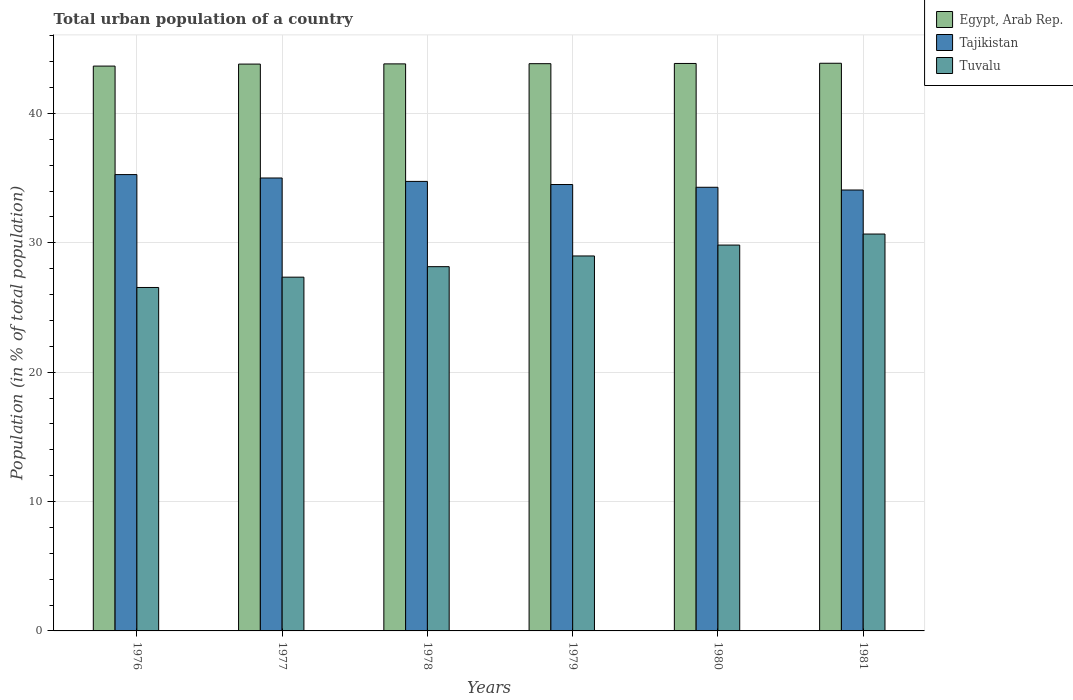Are the number of bars on each tick of the X-axis equal?
Offer a terse response. Yes. How many bars are there on the 4th tick from the right?
Provide a succinct answer. 3. What is the label of the 6th group of bars from the left?
Your answer should be very brief. 1981. What is the urban population in Tajikistan in 1980?
Make the answer very short. 34.29. Across all years, what is the maximum urban population in Tuvalu?
Your response must be concise. 30.68. Across all years, what is the minimum urban population in Tajikistan?
Your response must be concise. 34.08. In which year was the urban population in Egypt, Arab Rep. minimum?
Offer a very short reply. 1976. What is the total urban population in Egypt, Arab Rep. in the graph?
Your response must be concise. 262.87. What is the difference between the urban population in Tajikistan in 1977 and that in 1980?
Ensure brevity in your answer.  0.72. What is the difference between the urban population in Egypt, Arab Rep. in 1977 and the urban population in Tuvalu in 1976?
Offer a terse response. 17.27. What is the average urban population in Egypt, Arab Rep. per year?
Offer a very short reply. 43.81. In the year 1979, what is the difference between the urban population in Egypt, Arab Rep. and urban population in Tuvalu?
Make the answer very short. 14.86. What is the ratio of the urban population in Tuvalu in 1976 to that in 1978?
Your answer should be compact. 0.94. What is the difference between the highest and the second highest urban population in Tuvalu?
Give a very brief answer. 0.85. What is the difference between the highest and the lowest urban population in Tuvalu?
Your answer should be compact. 4.13. In how many years, is the urban population in Tajikistan greater than the average urban population in Tajikistan taken over all years?
Keep it short and to the point. 3. Is the sum of the urban population in Tajikistan in 1977 and 1978 greater than the maximum urban population in Tuvalu across all years?
Your answer should be very brief. Yes. What does the 3rd bar from the left in 1977 represents?
Ensure brevity in your answer.  Tuvalu. What does the 1st bar from the right in 1976 represents?
Offer a very short reply. Tuvalu. How many bars are there?
Offer a terse response. 18. Are all the bars in the graph horizontal?
Offer a very short reply. No. What is the difference between two consecutive major ticks on the Y-axis?
Your response must be concise. 10. Does the graph contain any zero values?
Your answer should be very brief. No. Does the graph contain grids?
Your answer should be very brief. Yes. What is the title of the graph?
Ensure brevity in your answer.  Total urban population of a country. Does "Georgia" appear as one of the legend labels in the graph?
Provide a succinct answer. No. What is the label or title of the X-axis?
Keep it short and to the point. Years. What is the label or title of the Y-axis?
Offer a very short reply. Population (in % of total population). What is the Population (in % of total population) of Egypt, Arab Rep. in 1976?
Offer a terse response. 43.66. What is the Population (in % of total population) of Tajikistan in 1976?
Ensure brevity in your answer.  35.27. What is the Population (in % of total population) of Tuvalu in 1976?
Ensure brevity in your answer.  26.55. What is the Population (in % of total population) of Egypt, Arab Rep. in 1977?
Provide a short and direct response. 43.81. What is the Population (in % of total population) in Tajikistan in 1977?
Offer a terse response. 35.01. What is the Population (in % of total population) in Tuvalu in 1977?
Offer a very short reply. 27.34. What is the Population (in % of total population) in Egypt, Arab Rep. in 1978?
Offer a very short reply. 43.83. What is the Population (in % of total population) in Tajikistan in 1978?
Provide a succinct answer. 34.74. What is the Population (in % of total population) of Tuvalu in 1978?
Give a very brief answer. 28.15. What is the Population (in % of total population) in Egypt, Arab Rep. in 1979?
Ensure brevity in your answer.  43.84. What is the Population (in % of total population) of Tajikistan in 1979?
Ensure brevity in your answer.  34.5. What is the Population (in % of total population) of Tuvalu in 1979?
Provide a short and direct response. 28.98. What is the Population (in % of total population) in Egypt, Arab Rep. in 1980?
Make the answer very short. 43.86. What is the Population (in % of total population) in Tajikistan in 1980?
Offer a terse response. 34.29. What is the Population (in % of total population) in Tuvalu in 1980?
Give a very brief answer. 29.82. What is the Population (in % of total population) of Egypt, Arab Rep. in 1981?
Make the answer very short. 43.87. What is the Population (in % of total population) of Tajikistan in 1981?
Your response must be concise. 34.08. What is the Population (in % of total population) of Tuvalu in 1981?
Give a very brief answer. 30.68. Across all years, what is the maximum Population (in % of total population) in Egypt, Arab Rep.?
Make the answer very short. 43.87. Across all years, what is the maximum Population (in % of total population) in Tajikistan?
Your response must be concise. 35.27. Across all years, what is the maximum Population (in % of total population) of Tuvalu?
Ensure brevity in your answer.  30.68. Across all years, what is the minimum Population (in % of total population) of Egypt, Arab Rep.?
Keep it short and to the point. 43.66. Across all years, what is the minimum Population (in % of total population) in Tajikistan?
Make the answer very short. 34.08. Across all years, what is the minimum Population (in % of total population) of Tuvalu?
Your answer should be compact. 26.55. What is the total Population (in % of total population) of Egypt, Arab Rep. in the graph?
Provide a succinct answer. 262.87. What is the total Population (in % of total population) in Tajikistan in the graph?
Give a very brief answer. 207.89. What is the total Population (in % of total population) in Tuvalu in the graph?
Keep it short and to the point. 171.52. What is the difference between the Population (in % of total population) of Egypt, Arab Rep. in 1976 and that in 1977?
Give a very brief answer. -0.15. What is the difference between the Population (in % of total population) of Tajikistan in 1976 and that in 1977?
Make the answer very short. 0.26. What is the difference between the Population (in % of total population) in Tuvalu in 1976 and that in 1977?
Ensure brevity in your answer.  -0.8. What is the difference between the Population (in % of total population) of Egypt, Arab Rep. in 1976 and that in 1978?
Offer a very short reply. -0.17. What is the difference between the Population (in % of total population) in Tajikistan in 1976 and that in 1978?
Offer a terse response. 0.53. What is the difference between the Population (in % of total population) of Tuvalu in 1976 and that in 1978?
Keep it short and to the point. -1.61. What is the difference between the Population (in % of total population) of Egypt, Arab Rep. in 1976 and that in 1979?
Ensure brevity in your answer.  -0.19. What is the difference between the Population (in % of total population) in Tajikistan in 1976 and that in 1979?
Provide a short and direct response. 0.77. What is the difference between the Population (in % of total population) of Tuvalu in 1976 and that in 1979?
Your answer should be very brief. -2.44. What is the difference between the Population (in % of total population) in Egypt, Arab Rep. in 1976 and that in 1980?
Give a very brief answer. -0.2. What is the difference between the Population (in % of total population) of Tajikistan in 1976 and that in 1980?
Provide a short and direct response. 0.98. What is the difference between the Population (in % of total population) in Tuvalu in 1976 and that in 1980?
Make the answer very short. -3.28. What is the difference between the Population (in % of total population) in Egypt, Arab Rep. in 1976 and that in 1981?
Give a very brief answer. -0.22. What is the difference between the Population (in % of total population) of Tajikistan in 1976 and that in 1981?
Provide a short and direct response. 1.19. What is the difference between the Population (in % of total population) in Tuvalu in 1976 and that in 1981?
Provide a succinct answer. -4.13. What is the difference between the Population (in % of total population) in Egypt, Arab Rep. in 1977 and that in 1978?
Provide a succinct answer. -0.02. What is the difference between the Population (in % of total population) of Tajikistan in 1977 and that in 1978?
Provide a short and direct response. 0.26. What is the difference between the Population (in % of total population) of Tuvalu in 1977 and that in 1978?
Offer a terse response. -0.81. What is the difference between the Population (in % of total population) of Egypt, Arab Rep. in 1977 and that in 1979?
Give a very brief answer. -0.03. What is the difference between the Population (in % of total population) in Tajikistan in 1977 and that in 1979?
Your answer should be very brief. 0.5. What is the difference between the Population (in % of total population) of Tuvalu in 1977 and that in 1979?
Keep it short and to the point. -1.64. What is the difference between the Population (in % of total population) in Egypt, Arab Rep. in 1977 and that in 1980?
Offer a very short reply. -0.05. What is the difference between the Population (in % of total population) in Tajikistan in 1977 and that in 1980?
Ensure brevity in your answer.  0.72. What is the difference between the Population (in % of total population) of Tuvalu in 1977 and that in 1980?
Provide a succinct answer. -2.48. What is the difference between the Population (in % of total population) of Egypt, Arab Rep. in 1977 and that in 1981?
Provide a succinct answer. -0.06. What is the difference between the Population (in % of total population) of Tajikistan in 1977 and that in 1981?
Offer a very short reply. 0.93. What is the difference between the Population (in % of total population) of Tuvalu in 1977 and that in 1981?
Offer a terse response. -3.33. What is the difference between the Population (in % of total population) in Egypt, Arab Rep. in 1978 and that in 1979?
Ensure brevity in your answer.  -0.02. What is the difference between the Population (in % of total population) of Tajikistan in 1978 and that in 1979?
Your answer should be very brief. 0.24. What is the difference between the Population (in % of total population) of Tuvalu in 1978 and that in 1979?
Provide a short and direct response. -0.83. What is the difference between the Population (in % of total population) of Egypt, Arab Rep. in 1978 and that in 1980?
Your answer should be compact. -0.03. What is the difference between the Population (in % of total population) of Tajikistan in 1978 and that in 1980?
Provide a succinct answer. 0.45. What is the difference between the Population (in % of total population) in Tuvalu in 1978 and that in 1980?
Offer a very short reply. -1.67. What is the difference between the Population (in % of total population) in Egypt, Arab Rep. in 1978 and that in 1981?
Provide a succinct answer. -0.05. What is the difference between the Population (in % of total population) of Tajikistan in 1978 and that in 1981?
Provide a succinct answer. 0.67. What is the difference between the Population (in % of total population) of Tuvalu in 1978 and that in 1981?
Your answer should be compact. -2.52. What is the difference between the Population (in % of total population) of Egypt, Arab Rep. in 1979 and that in 1980?
Offer a very short reply. -0.02. What is the difference between the Population (in % of total population) in Tajikistan in 1979 and that in 1980?
Make the answer very short. 0.21. What is the difference between the Population (in % of total population) of Tuvalu in 1979 and that in 1980?
Give a very brief answer. -0.84. What is the difference between the Population (in % of total population) in Egypt, Arab Rep. in 1979 and that in 1981?
Give a very brief answer. -0.03. What is the difference between the Population (in % of total population) in Tajikistan in 1979 and that in 1981?
Provide a short and direct response. 0.42. What is the difference between the Population (in % of total population) in Tuvalu in 1979 and that in 1981?
Ensure brevity in your answer.  -1.7. What is the difference between the Population (in % of total population) of Egypt, Arab Rep. in 1980 and that in 1981?
Provide a succinct answer. -0.02. What is the difference between the Population (in % of total population) of Tajikistan in 1980 and that in 1981?
Offer a terse response. 0.21. What is the difference between the Population (in % of total population) of Tuvalu in 1980 and that in 1981?
Make the answer very short. -0.85. What is the difference between the Population (in % of total population) in Egypt, Arab Rep. in 1976 and the Population (in % of total population) in Tajikistan in 1977?
Keep it short and to the point. 8.65. What is the difference between the Population (in % of total population) of Egypt, Arab Rep. in 1976 and the Population (in % of total population) of Tuvalu in 1977?
Make the answer very short. 16.32. What is the difference between the Population (in % of total population) in Tajikistan in 1976 and the Population (in % of total population) in Tuvalu in 1977?
Ensure brevity in your answer.  7.93. What is the difference between the Population (in % of total population) in Egypt, Arab Rep. in 1976 and the Population (in % of total population) in Tajikistan in 1978?
Keep it short and to the point. 8.91. What is the difference between the Population (in % of total population) in Egypt, Arab Rep. in 1976 and the Population (in % of total population) in Tuvalu in 1978?
Give a very brief answer. 15.5. What is the difference between the Population (in % of total population) in Tajikistan in 1976 and the Population (in % of total population) in Tuvalu in 1978?
Your answer should be very brief. 7.12. What is the difference between the Population (in % of total population) in Egypt, Arab Rep. in 1976 and the Population (in % of total population) in Tajikistan in 1979?
Provide a short and direct response. 9.15. What is the difference between the Population (in % of total population) of Egypt, Arab Rep. in 1976 and the Population (in % of total population) of Tuvalu in 1979?
Ensure brevity in your answer.  14.68. What is the difference between the Population (in % of total population) in Tajikistan in 1976 and the Population (in % of total population) in Tuvalu in 1979?
Your response must be concise. 6.29. What is the difference between the Population (in % of total population) in Egypt, Arab Rep. in 1976 and the Population (in % of total population) in Tajikistan in 1980?
Your answer should be compact. 9.37. What is the difference between the Population (in % of total population) in Egypt, Arab Rep. in 1976 and the Population (in % of total population) in Tuvalu in 1980?
Provide a succinct answer. 13.83. What is the difference between the Population (in % of total population) of Tajikistan in 1976 and the Population (in % of total population) of Tuvalu in 1980?
Your answer should be very brief. 5.45. What is the difference between the Population (in % of total population) in Egypt, Arab Rep. in 1976 and the Population (in % of total population) in Tajikistan in 1981?
Your answer should be compact. 9.58. What is the difference between the Population (in % of total population) of Egypt, Arab Rep. in 1976 and the Population (in % of total population) of Tuvalu in 1981?
Make the answer very short. 12.98. What is the difference between the Population (in % of total population) of Tajikistan in 1976 and the Population (in % of total population) of Tuvalu in 1981?
Offer a terse response. 4.59. What is the difference between the Population (in % of total population) in Egypt, Arab Rep. in 1977 and the Population (in % of total population) in Tajikistan in 1978?
Give a very brief answer. 9.07. What is the difference between the Population (in % of total population) in Egypt, Arab Rep. in 1977 and the Population (in % of total population) in Tuvalu in 1978?
Ensure brevity in your answer.  15.66. What is the difference between the Population (in % of total population) of Tajikistan in 1977 and the Population (in % of total population) of Tuvalu in 1978?
Your response must be concise. 6.85. What is the difference between the Population (in % of total population) in Egypt, Arab Rep. in 1977 and the Population (in % of total population) in Tajikistan in 1979?
Make the answer very short. 9.31. What is the difference between the Population (in % of total population) of Egypt, Arab Rep. in 1977 and the Population (in % of total population) of Tuvalu in 1979?
Your answer should be very brief. 14.83. What is the difference between the Population (in % of total population) of Tajikistan in 1977 and the Population (in % of total population) of Tuvalu in 1979?
Provide a short and direct response. 6.03. What is the difference between the Population (in % of total population) of Egypt, Arab Rep. in 1977 and the Population (in % of total population) of Tajikistan in 1980?
Your answer should be very brief. 9.52. What is the difference between the Population (in % of total population) of Egypt, Arab Rep. in 1977 and the Population (in % of total population) of Tuvalu in 1980?
Keep it short and to the point. 13.99. What is the difference between the Population (in % of total population) of Tajikistan in 1977 and the Population (in % of total population) of Tuvalu in 1980?
Keep it short and to the point. 5.18. What is the difference between the Population (in % of total population) of Egypt, Arab Rep. in 1977 and the Population (in % of total population) of Tajikistan in 1981?
Offer a terse response. 9.73. What is the difference between the Population (in % of total population) in Egypt, Arab Rep. in 1977 and the Population (in % of total population) in Tuvalu in 1981?
Offer a terse response. 13.13. What is the difference between the Population (in % of total population) of Tajikistan in 1977 and the Population (in % of total population) of Tuvalu in 1981?
Give a very brief answer. 4.33. What is the difference between the Population (in % of total population) of Egypt, Arab Rep. in 1978 and the Population (in % of total population) of Tajikistan in 1979?
Your answer should be very brief. 9.32. What is the difference between the Population (in % of total population) in Egypt, Arab Rep. in 1978 and the Population (in % of total population) in Tuvalu in 1979?
Your answer should be compact. 14.85. What is the difference between the Population (in % of total population) in Tajikistan in 1978 and the Population (in % of total population) in Tuvalu in 1979?
Your answer should be very brief. 5.76. What is the difference between the Population (in % of total population) of Egypt, Arab Rep. in 1978 and the Population (in % of total population) of Tajikistan in 1980?
Provide a short and direct response. 9.54. What is the difference between the Population (in % of total population) in Egypt, Arab Rep. in 1978 and the Population (in % of total population) in Tuvalu in 1980?
Your answer should be compact. 14. What is the difference between the Population (in % of total population) in Tajikistan in 1978 and the Population (in % of total population) in Tuvalu in 1980?
Keep it short and to the point. 4.92. What is the difference between the Population (in % of total population) in Egypt, Arab Rep. in 1978 and the Population (in % of total population) in Tajikistan in 1981?
Offer a terse response. 9.75. What is the difference between the Population (in % of total population) in Egypt, Arab Rep. in 1978 and the Population (in % of total population) in Tuvalu in 1981?
Your answer should be compact. 13.15. What is the difference between the Population (in % of total population) in Tajikistan in 1978 and the Population (in % of total population) in Tuvalu in 1981?
Give a very brief answer. 4.07. What is the difference between the Population (in % of total population) of Egypt, Arab Rep. in 1979 and the Population (in % of total population) of Tajikistan in 1980?
Give a very brief answer. 9.55. What is the difference between the Population (in % of total population) in Egypt, Arab Rep. in 1979 and the Population (in % of total population) in Tuvalu in 1980?
Your answer should be very brief. 14.02. What is the difference between the Population (in % of total population) in Tajikistan in 1979 and the Population (in % of total population) in Tuvalu in 1980?
Your answer should be compact. 4.68. What is the difference between the Population (in % of total population) in Egypt, Arab Rep. in 1979 and the Population (in % of total population) in Tajikistan in 1981?
Make the answer very short. 9.76. What is the difference between the Population (in % of total population) in Egypt, Arab Rep. in 1979 and the Population (in % of total population) in Tuvalu in 1981?
Make the answer very short. 13.17. What is the difference between the Population (in % of total population) in Tajikistan in 1979 and the Population (in % of total population) in Tuvalu in 1981?
Offer a very short reply. 3.83. What is the difference between the Population (in % of total population) in Egypt, Arab Rep. in 1980 and the Population (in % of total population) in Tajikistan in 1981?
Offer a terse response. 9.78. What is the difference between the Population (in % of total population) in Egypt, Arab Rep. in 1980 and the Population (in % of total population) in Tuvalu in 1981?
Ensure brevity in your answer.  13.18. What is the difference between the Population (in % of total population) in Tajikistan in 1980 and the Population (in % of total population) in Tuvalu in 1981?
Ensure brevity in your answer.  3.61. What is the average Population (in % of total population) of Egypt, Arab Rep. per year?
Your response must be concise. 43.81. What is the average Population (in % of total population) in Tajikistan per year?
Offer a very short reply. 34.65. What is the average Population (in % of total population) of Tuvalu per year?
Provide a short and direct response. 28.59. In the year 1976, what is the difference between the Population (in % of total population) of Egypt, Arab Rep. and Population (in % of total population) of Tajikistan?
Provide a succinct answer. 8.39. In the year 1976, what is the difference between the Population (in % of total population) of Egypt, Arab Rep. and Population (in % of total population) of Tuvalu?
Provide a succinct answer. 17.11. In the year 1976, what is the difference between the Population (in % of total population) in Tajikistan and Population (in % of total population) in Tuvalu?
Keep it short and to the point. 8.72. In the year 1977, what is the difference between the Population (in % of total population) in Egypt, Arab Rep. and Population (in % of total population) in Tajikistan?
Make the answer very short. 8.8. In the year 1977, what is the difference between the Population (in % of total population) in Egypt, Arab Rep. and Population (in % of total population) in Tuvalu?
Your answer should be compact. 16.47. In the year 1977, what is the difference between the Population (in % of total population) in Tajikistan and Population (in % of total population) in Tuvalu?
Your answer should be compact. 7.67. In the year 1978, what is the difference between the Population (in % of total population) of Egypt, Arab Rep. and Population (in % of total population) of Tajikistan?
Give a very brief answer. 9.08. In the year 1978, what is the difference between the Population (in % of total population) in Egypt, Arab Rep. and Population (in % of total population) in Tuvalu?
Make the answer very short. 15.67. In the year 1978, what is the difference between the Population (in % of total population) of Tajikistan and Population (in % of total population) of Tuvalu?
Your response must be concise. 6.59. In the year 1979, what is the difference between the Population (in % of total population) in Egypt, Arab Rep. and Population (in % of total population) in Tajikistan?
Offer a very short reply. 9.34. In the year 1979, what is the difference between the Population (in % of total population) in Egypt, Arab Rep. and Population (in % of total population) in Tuvalu?
Give a very brief answer. 14.86. In the year 1979, what is the difference between the Population (in % of total population) of Tajikistan and Population (in % of total population) of Tuvalu?
Make the answer very short. 5.52. In the year 1980, what is the difference between the Population (in % of total population) in Egypt, Arab Rep. and Population (in % of total population) in Tajikistan?
Offer a very short reply. 9.57. In the year 1980, what is the difference between the Population (in % of total population) in Egypt, Arab Rep. and Population (in % of total population) in Tuvalu?
Make the answer very short. 14.04. In the year 1980, what is the difference between the Population (in % of total population) of Tajikistan and Population (in % of total population) of Tuvalu?
Offer a very short reply. 4.47. In the year 1981, what is the difference between the Population (in % of total population) of Egypt, Arab Rep. and Population (in % of total population) of Tajikistan?
Give a very brief answer. 9.8. In the year 1981, what is the difference between the Population (in % of total population) in Egypt, Arab Rep. and Population (in % of total population) in Tuvalu?
Offer a very short reply. 13.2. In the year 1981, what is the difference between the Population (in % of total population) of Tajikistan and Population (in % of total population) of Tuvalu?
Ensure brevity in your answer.  3.4. What is the ratio of the Population (in % of total population) in Tajikistan in 1976 to that in 1977?
Make the answer very short. 1.01. What is the ratio of the Population (in % of total population) of Tuvalu in 1976 to that in 1977?
Provide a succinct answer. 0.97. What is the ratio of the Population (in % of total population) of Tajikistan in 1976 to that in 1978?
Your answer should be very brief. 1.02. What is the ratio of the Population (in % of total population) of Tuvalu in 1976 to that in 1978?
Your response must be concise. 0.94. What is the ratio of the Population (in % of total population) in Tajikistan in 1976 to that in 1979?
Provide a short and direct response. 1.02. What is the ratio of the Population (in % of total population) in Tuvalu in 1976 to that in 1979?
Your response must be concise. 0.92. What is the ratio of the Population (in % of total population) in Egypt, Arab Rep. in 1976 to that in 1980?
Provide a succinct answer. 1. What is the ratio of the Population (in % of total population) in Tajikistan in 1976 to that in 1980?
Offer a very short reply. 1.03. What is the ratio of the Population (in % of total population) in Tuvalu in 1976 to that in 1980?
Offer a very short reply. 0.89. What is the ratio of the Population (in % of total population) of Tajikistan in 1976 to that in 1981?
Give a very brief answer. 1.03. What is the ratio of the Population (in % of total population) of Tuvalu in 1976 to that in 1981?
Make the answer very short. 0.87. What is the ratio of the Population (in % of total population) of Tajikistan in 1977 to that in 1978?
Provide a short and direct response. 1.01. What is the ratio of the Population (in % of total population) in Tuvalu in 1977 to that in 1978?
Offer a terse response. 0.97. What is the ratio of the Population (in % of total population) in Tajikistan in 1977 to that in 1979?
Keep it short and to the point. 1.01. What is the ratio of the Population (in % of total population) in Tuvalu in 1977 to that in 1979?
Provide a succinct answer. 0.94. What is the ratio of the Population (in % of total population) of Tajikistan in 1977 to that in 1980?
Make the answer very short. 1.02. What is the ratio of the Population (in % of total population) of Tuvalu in 1977 to that in 1980?
Ensure brevity in your answer.  0.92. What is the ratio of the Population (in % of total population) of Tajikistan in 1977 to that in 1981?
Provide a succinct answer. 1.03. What is the ratio of the Population (in % of total population) in Tuvalu in 1977 to that in 1981?
Offer a terse response. 0.89. What is the ratio of the Population (in % of total population) of Tajikistan in 1978 to that in 1979?
Your answer should be very brief. 1.01. What is the ratio of the Population (in % of total population) in Tuvalu in 1978 to that in 1979?
Keep it short and to the point. 0.97. What is the ratio of the Population (in % of total population) in Tajikistan in 1978 to that in 1980?
Ensure brevity in your answer.  1.01. What is the ratio of the Population (in % of total population) of Tuvalu in 1978 to that in 1980?
Provide a short and direct response. 0.94. What is the ratio of the Population (in % of total population) in Tajikistan in 1978 to that in 1981?
Your answer should be compact. 1.02. What is the ratio of the Population (in % of total population) in Tuvalu in 1978 to that in 1981?
Provide a succinct answer. 0.92. What is the ratio of the Population (in % of total population) of Egypt, Arab Rep. in 1979 to that in 1980?
Your answer should be very brief. 1. What is the ratio of the Population (in % of total population) in Tuvalu in 1979 to that in 1980?
Your answer should be compact. 0.97. What is the ratio of the Population (in % of total population) of Egypt, Arab Rep. in 1979 to that in 1981?
Make the answer very short. 1. What is the ratio of the Population (in % of total population) in Tajikistan in 1979 to that in 1981?
Your answer should be compact. 1.01. What is the ratio of the Population (in % of total population) of Tuvalu in 1979 to that in 1981?
Make the answer very short. 0.94. What is the ratio of the Population (in % of total population) of Tajikistan in 1980 to that in 1981?
Your response must be concise. 1.01. What is the ratio of the Population (in % of total population) of Tuvalu in 1980 to that in 1981?
Your response must be concise. 0.97. What is the difference between the highest and the second highest Population (in % of total population) in Egypt, Arab Rep.?
Make the answer very short. 0.02. What is the difference between the highest and the second highest Population (in % of total population) of Tajikistan?
Your answer should be compact. 0.26. What is the difference between the highest and the second highest Population (in % of total population) of Tuvalu?
Your response must be concise. 0.85. What is the difference between the highest and the lowest Population (in % of total population) of Egypt, Arab Rep.?
Your answer should be very brief. 0.22. What is the difference between the highest and the lowest Population (in % of total population) of Tajikistan?
Make the answer very short. 1.19. What is the difference between the highest and the lowest Population (in % of total population) of Tuvalu?
Give a very brief answer. 4.13. 